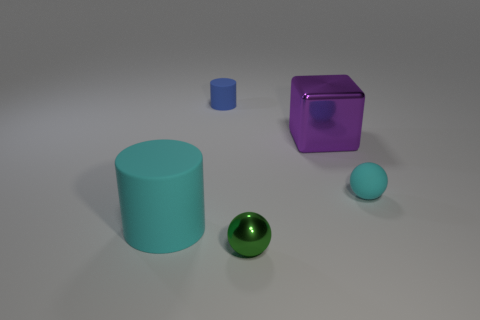Add 4 shiny things. How many objects exist? 9 Subtract all spheres. How many objects are left? 3 Add 4 tiny cyan objects. How many tiny cyan objects exist? 5 Subtract 0 gray cubes. How many objects are left? 5 Subtract all large cyan matte objects. Subtract all large brown metallic things. How many objects are left? 4 Add 2 rubber objects. How many rubber objects are left? 5 